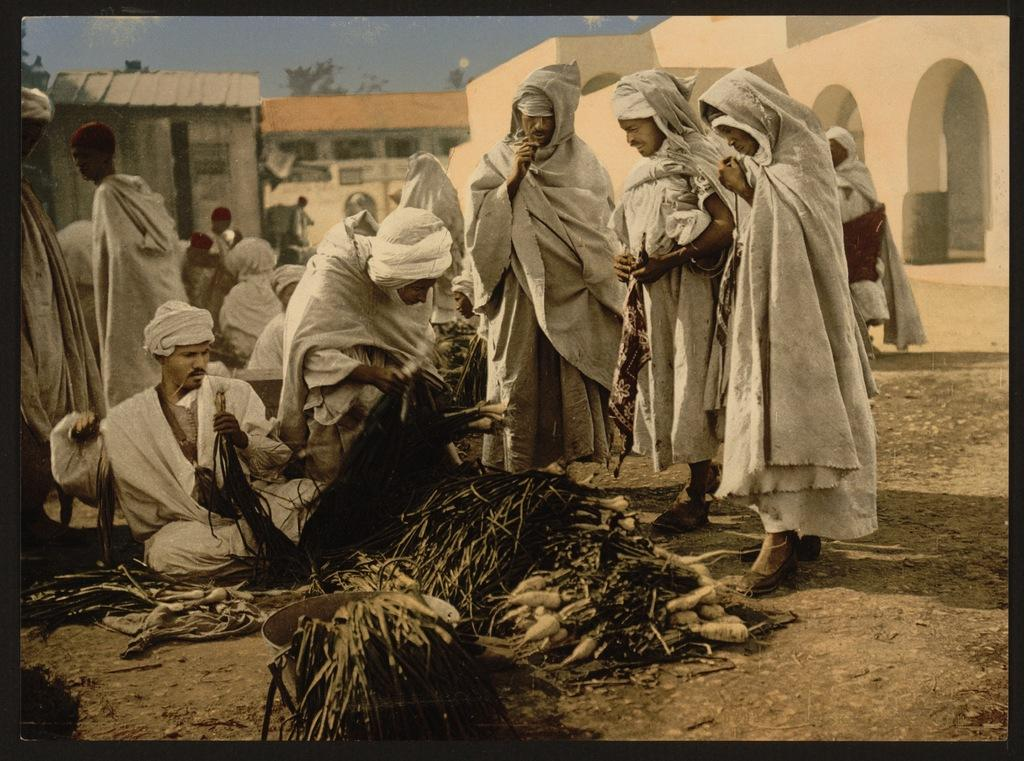What object is present in the image? There is a photo frame in the image. What can be seen inside the photo frame? The photo frame contains a group of people, food items, trees, and buildings. What is visible in the background of the photo frame? The sky is visible in the background of the photo frame. What type of crown is worn by the person in the photo frame? There is no crown visible in the photo frame; it only contains a group of people, food items, trees, and buildings. 